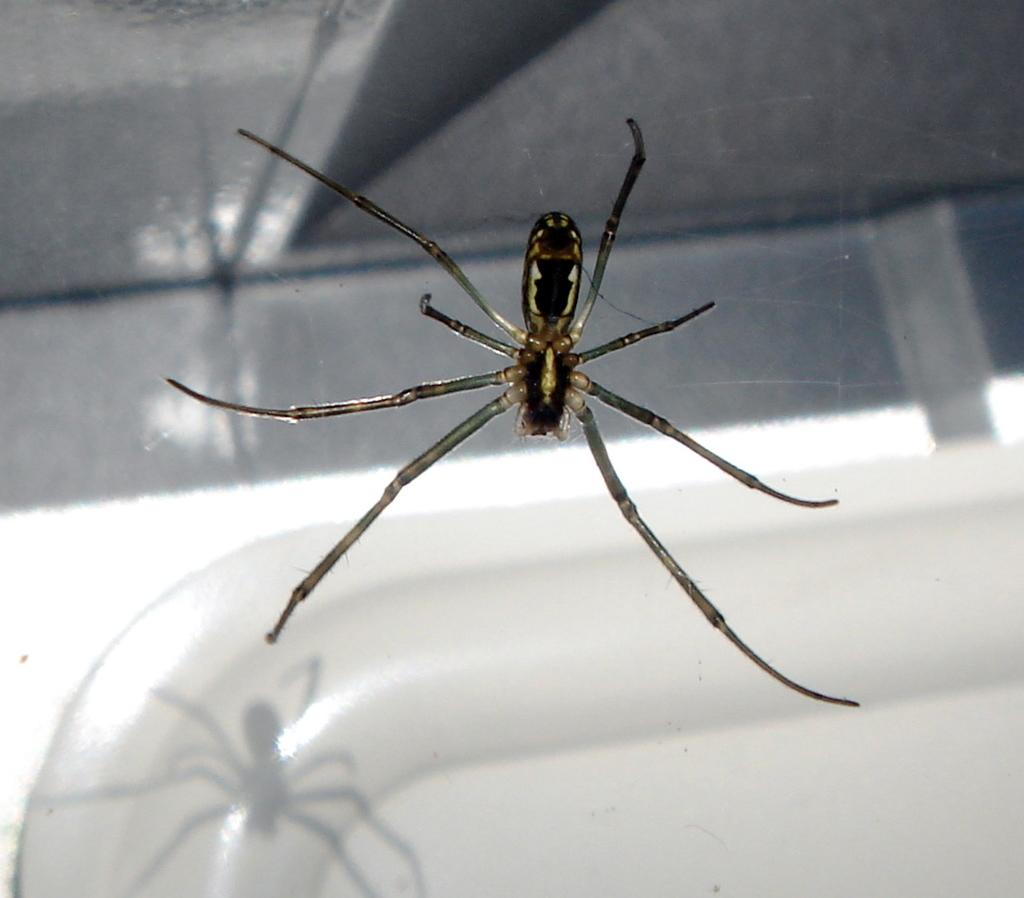What type of animal is present in the image? There is a spider in the image. What type of plants can be seen growing near the spider in the image? There is no information about plants in the image, as the only fact provided is the presence of a spider. 